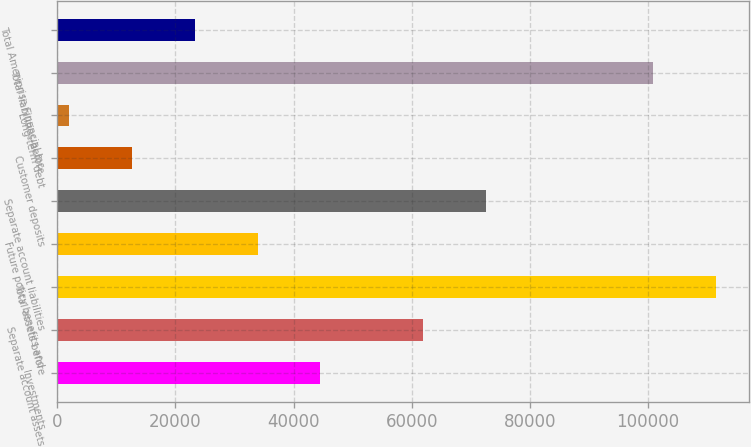Convert chart to OTSL. <chart><loc_0><loc_0><loc_500><loc_500><bar_chart><fcel>Investments<fcel>Separate account assets<fcel>Total assets before<fcel>Future policy benefits and<fcel>Separate account liabilities<fcel>Customer deposits<fcel>Long-term debt<fcel>Total liabilities before<fcel>Total Ameriprise Financial Inc<nl><fcel>44559.2<fcel>61974<fcel>111443<fcel>33923.9<fcel>72609.3<fcel>12653.3<fcel>2018<fcel>100808<fcel>23288.6<nl></chart> 